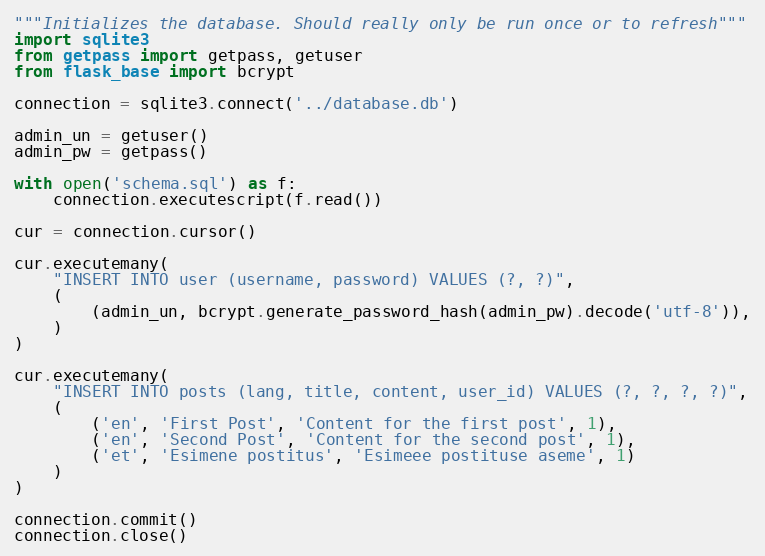Convert code to text. <code><loc_0><loc_0><loc_500><loc_500><_Python_>"""Initializes the database. Should really only be run once or to refresh"""
import sqlite3
from getpass import getpass, getuser
from flask_base import bcrypt

connection = sqlite3.connect('../database.db')

admin_un = getuser()
admin_pw = getpass()

with open('schema.sql') as f:
    connection.executescript(f.read())

cur = connection.cursor()

cur.executemany(
    "INSERT INTO user (username, password) VALUES (?, ?)",
    (
        (admin_un, bcrypt.generate_password_hash(admin_pw).decode('utf-8')),
    )
)

cur.executemany(
    "INSERT INTO posts (lang, title, content, user_id) VALUES (?, ?, ?, ?)",
    (
        ('en', 'First Post', 'Content for the first post', 1),
        ('en', 'Second Post', 'Content for the second post', 1),
        ('et', 'Esimene postitus', 'Esimeee postituse aseme', 1)
    )
)

connection.commit()
connection.close()
</code> 